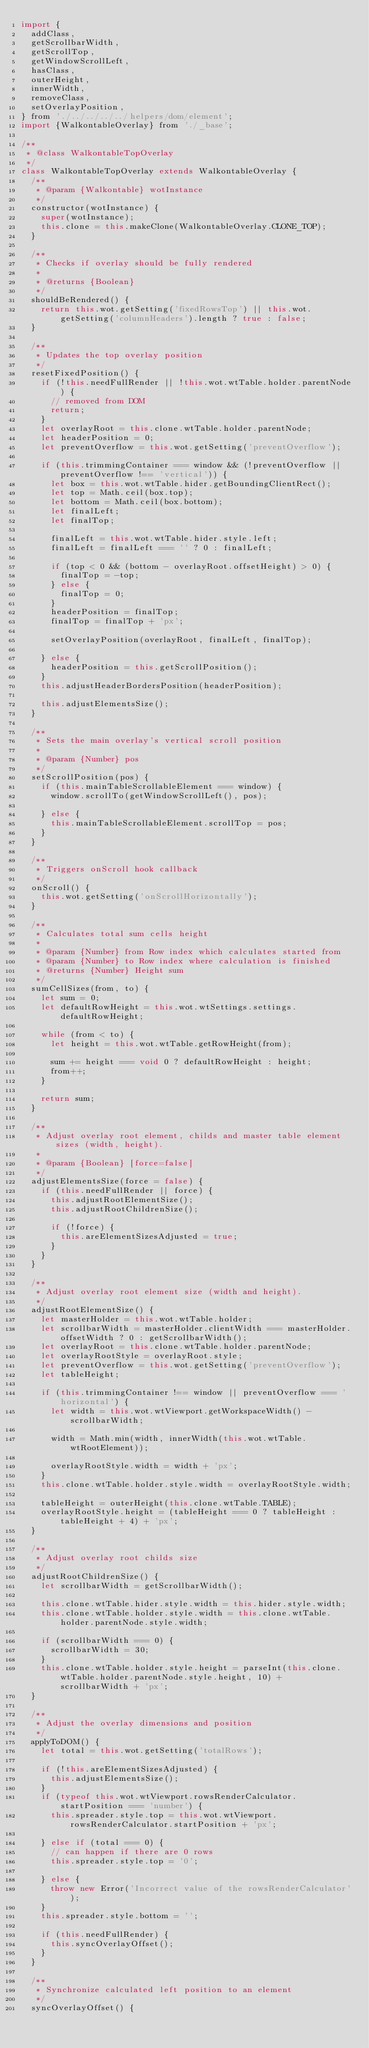<code> <loc_0><loc_0><loc_500><loc_500><_JavaScript_>import {
  addClass,
  getScrollbarWidth,
  getScrollTop,
  getWindowScrollLeft,
  hasClass,
  outerHeight,
  innerWidth,
  removeClass,
  setOverlayPosition,
} from './../../../../helpers/dom/element';
import {WalkontableOverlay} from './_base';

/**
 * @class WalkontableTopOverlay
 */
class WalkontableTopOverlay extends WalkontableOverlay {
  /**
   * @param {Walkontable} wotInstance
   */
  constructor(wotInstance) {
    super(wotInstance);
    this.clone = this.makeClone(WalkontableOverlay.CLONE_TOP);
  }

  /**
   * Checks if overlay should be fully rendered
   *
   * @returns {Boolean}
   */
  shouldBeRendered() {
    return this.wot.getSetting('fixedRowsTop') || this.wot.getSetting('columnHeaders').length ? true : false;
  }

  /**
   * Updates the top overlay position
   */
  resetFixedPosition() {
    if (!this.needFullRender || !this.wot.wtTable.holder.parentNode) {
      // removed from DOM
      return;
    }
    let overlayRoot = this.clone.wtTable.holder.parentNode;
    let headerPosition = 0;
    let preventOverflow = this.wot.getSetting('preventOverflow');

    if (this.trimmingContainer === window && (!preventOverflow || preventOverflow !== 'vertical')) {
      let box = this.wot.wtTable.hider.getBoundingClientRect();
      let top = Math.ceil(box.top);
      let bottom = Math.ceil(box.bottom);
      let finalLeft;
      let finalTop;

      finalLeft = this.wot.wtTable.hider.style.left;
      finalLeft = finalLeft === '' ? 0 : finalLeft;

      if (top < 0 && (bottom - overlayRoot.offsetHeight) > 0) {
        finalTop = -top;
      } else {
        finalTop = 0;
      }
      headerPosition = finalTop;
      finalTop = finalTop + 'px';

      setOverlayPosition(overlayRoot, finalLeft, finalTop);

    } else {
      headerPosition = this.getScrollPosition();
    }
    this.adjustHeaderBordersPosition(headerPosition);

    this.adjustElementsSize();
  }

  /**
   * Sets the main overlay's vertical scroll position
   *
   * @param {Number} pos
   */
  setScrollPosition(pos) {
    if (this.mainTableScrollableElement === window) {
      window.scrollTo(getWindowScrollLeft(), pos);

    } else {
      this.mainTableScrollableElement.scrollTop = pos;
    }
  }

  /**
   * Triggers onScroll hook callback
   */
  onScroll() {
    this.wot.getSetting('onScrollHorizontally');
  }

  /**
   * Calculates total sum cells height
   *
   * @param {Number} from Row index which calculates started from
   * @param {Number} to Row index where calculation is finished
   * @returns {Number} Height sum
   */
  sumCellSizes(from, to) {
    let sum = 0;
    let defaultRowHeight = this.wot.wtSettings.settings.defaultRowHeight;

    while (from < to) {
      let height = this.wot.wtTable.getRowHeight(from);

      sum += height === void 0 ? defaultRowHeight : height;
      from++;
    }

    return sum;
  }

  /**
   * Adjust overlay root element, childs and master table element sizes (width, height).
   *
   * @param {Boolean} [force=false]
   */
  adjustElementsSize(force = false) {
    if (this.needFullRender || force) {
      this.adjustRootElementSize();
      this.adjustRootChildrenSize();

      if (!force) {
        this.areElementSizesAdjusted = true;
      }
    }
  }

  /**
   * Adjust overlay root element size (width and height).
   */
  adjustRootElementSize() {
    let masterHolder = this.wot.wtTable.holder;
    let scrollbarWidth = masterHolder.clientWidth === masterHolder.offsetWidth ? 0 : getScrollbarWidth();
    let overlayRoot = this.clone.wtTable.holder.parentNode;
    let overlayRootStyle = overlayRoot.style;
    let preventOverflow = this.wot.getSetting('preventOverflow');
    let tableHeight;

    if (this.trimmingContainer !== window || preventOverflow === 'horizontal') {
      let width = this.wot.wtViewport.getWorkspaceWidth() - scrollbarWidth;

      width = Math.min(width, innerWidth(this.wot.wtTable.wtRootElement));

      overlayRootStyle.width = width + 'px';
    }
    this.clone.wtTable.holder.style.width = overlayRootStyle.width;

    tableHeight = outerHeight(this.clone.wtTable.TABLE);
    overlayRootStyle.height = (tableHeight === 0 ? tableHeight : tableHeight + 4) + 'px';
  }

  /**
   * Adjust overlay root childs size
   */
  adjustRootChildrenSize() {
    let scrollbarWidth = getScrollbarWidth();

    this.clone.wtTable.hider.style.width = this.hider.style.width;
    this.clone.wtTable.holder.style.width = this.clone.wtTable.holder.parentNode.style.width;

    if (scrollbarWidth === 0) {
      scrollbarWidth = 30;
    }
    this.clone.wtTable.holder.style.height = parseInt(this.clone.wtTable.holder.parentNode.style.height, 10) + scrollbarWidth + 'px';
  }

  /**
   * Adjust the overlay dimensions and position
   */
  applyToDOM() {
    let total = this.wot.getSetting('totalRows');

    if (!this.areElementSizesAdjusted) {
      this.adjustElementsSize();
    }
    if (typeof this.wot.wtViewport.rowsRenderCalculator.startPosition === 'number') {
      this.spreader.style.top = this.wot.wtViewport.rowsRenderCalculator.startPosition + 'px';

    } else if (total === 0) {
      // can happen if there are 0 rows
      this.spreader.style.top = '0';

    } else {
      throw new Error('Incorrect value of the rowsRenderCalculator');
    }
    this.spreader.style.bottom = '';

    if (this.needFullRender) {
      this.syncOverlayOffset();
    }
  }

  /**
   * Synchronize calculated left position to an element
   */
  syncOverlayOffset() {</code> 